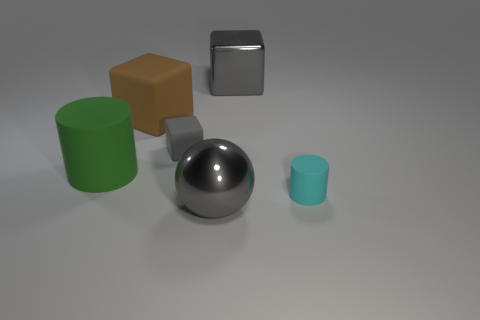Are there any other things that are the same material as the brown cube?
Ensure brevity in your answer.  Yes. There is a big cube that is the same color as the big sphere; what is it made of?
Offer a terse response. Metal. What is the material of the large gray thing to the right of the gray metal ball?
Give a very brief answer. Metal. The metal block has what size?
Your answer should be very brief. Large. What number of gray things are either shiny balls or tiny rubber blocks?
Offer a terse response. 2. How big is the matte object that is to the right of the big gray object behind the cyan cylinder?
Keep it short and to the point. Small. Does the shiny sphere have the same color as the large metallic object on the right side of the ball?
Your answer should be very brief. Yes. How many other objects are the same material as the big brown thing?
Provide a succinct answer. 3. There is a tiny gray object that is made of the same material as the tiny cyan object; what is its shape?
Keep it short and to the point. Cube. Is there anything else that has the same color as the ball?
Your response must be concise. Yes. 